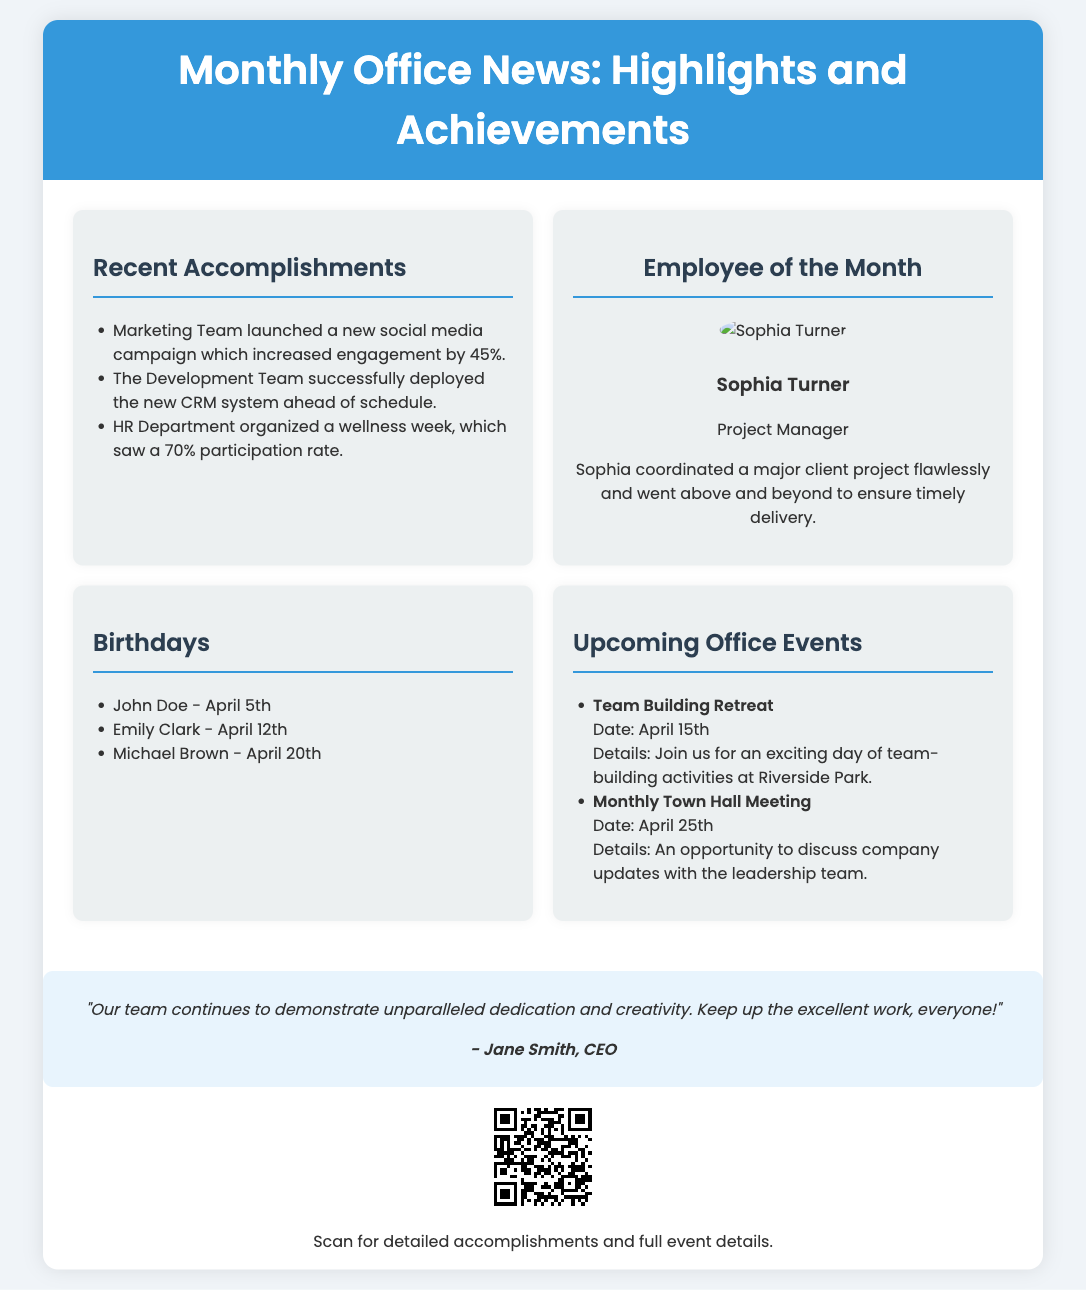What is the title of the flyer? The title of the flyer is stated in the header section, summarizing the main focus of the document.
Answer: Monthly Office News: Highlights and Achievements Who is the Employee of the Month? The flyer highlights a specific employee recognized for their achievements during the month.
Answer: Sophia Turner What date is the Team Building Retreat scheduled for? The event's date is explicitly mentioned in the section dedicated to upcoming events.
Answer: April 15th How much did engagement increase by due to the new social media campaign? This is a specific achievement stated in the accomplishments section of the document.
Answer: 45% What is the main quote from the CEO? The quote provides insight into leadership's appreciation for the team's work.
Answer: "Our team continues to demonstrate unparalleled dedication and creativity. Keep up the excellent work, everyone!" What rate of participation did the wellness week achieve? The engagement level for the wellness initiative is specifically stated.
Answer: 70% Which department organized the wellness week? Identifying this department is crucial for understanding the accomplishment highlighted.
Answer: HR Department What is the topic of the Monthly Town Hall Meeting? The purpose of this meeting is specified in the upcoming events section.
Answer: Company updates What is included in the QR code? The content linked by the QR code is vital for accessing additional information.
Answer: Detailed accomplishments and full event details 